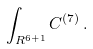Convert formula to latex. <formula><loc_0><loc_0><loc_500><loc_500>\int _ { R ^ { 6 + 1 } } C ^ { ( 7 ) } \, .</formula> 